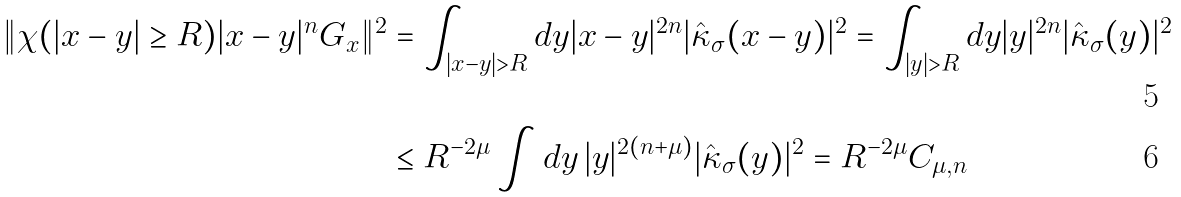Convert formula to latex. <formula><loc_0><loc_0><loc_500><loc_500>\| \chi ( | x - y | \geq R ) | x - y | ^ { n } G _ { x } \| ^ { 2 } & = \int _ { | x - y | > R } d y | x - y | ^ { 2 n } | \hat { \kappa } _ { \sigma } ( x - y ) | ^ { 2 } = \int _ { | y | > R } d y | y | ^ { 2 n } | \hat { \kappa } _ { \sigma } ( y ) | ^ { 2 } \\ & \leq R ^ { - 2 \mu } \int d y \, | y | ^ { 2 ( n + \mu ) } | \hat { \kappa } _ { \sigma } ( y ) | ^ { 2 } = R ^ { - 2 \mu } C _ { \mu , n }</formula> 